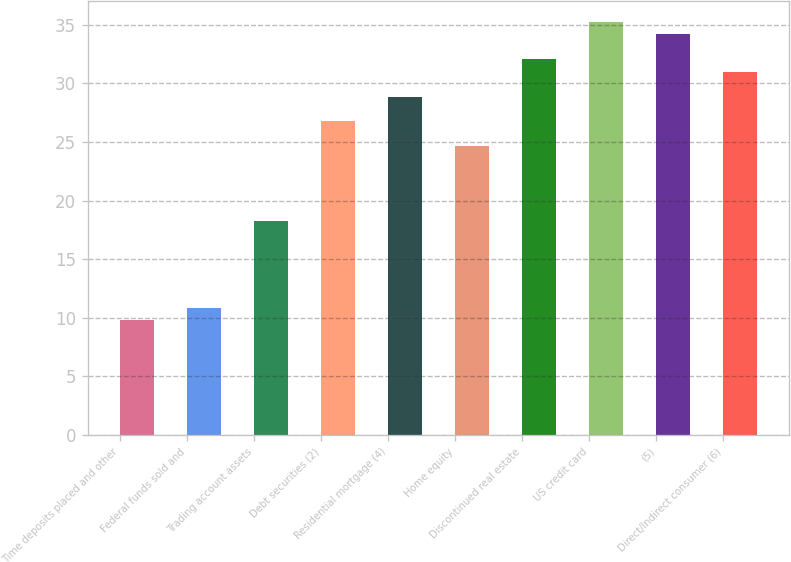Convert chart to OTSL. <chart><loc_0><loc_0><loc_500><loc_500><bar_chart><fcel>Time deposits placed and other<fcel>Federal funds sold and<fcel>Trading account assets<fcel>Debt securities (2)<fcel>Residential mortgage (4)<fcel>Home equity<fcel>Discontinued real estate<fcel>US credit card<fcel>(5)<fcel>Direct/Indirect consumer (6)<nl><fcel>9.8<fcel>10.86<fcel>18.28<fcel>26.76<fcel>28.88<fcel>24.64<fcel>32.06<fcel>35.24<fcel>34.18<fcel>31<nl></chart> 